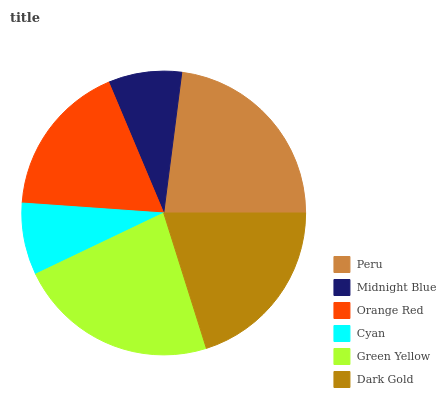Is Cyan the minimum?
Answer yes or no. Yes. Is Peru the maximum?
Answer yes or no. Yes. Is Midnight Blue the minimum?
Answer yes or no. No. Is Midnight Blue the maximum?
Answer yes or no. No. Is Peru greater than Midnight Blue?
Answer yes or no. Yes. Is Midnight Blue less than Peru?
Answer yes or no. Yes. Is Midnight Blue greater than Peru?
Answer yes or no. No. Is Peru less than Midnight Blue?
Answer yes or no. No. Is Dark Gold the high median?
Answer yes or no. Yes. Is Orange Red the low median?
Answer yes or no. Yes. Is Peru the high median?
Answer yes or no. No. Is Cyan the low median?
Answer yes or no. No. 